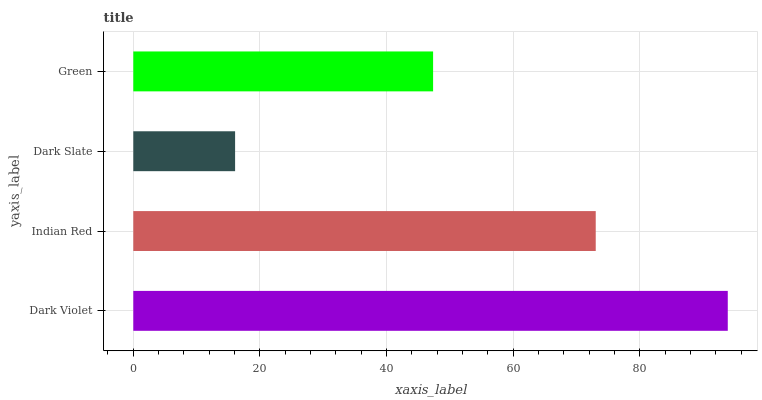Is Dark Slate the minimum?
Answer yes or no. Yes. Is Dark Violet the maximum?
Answer yes or no. Yes. Is Indian Red the minimum?
Answer yes or no. No. Is Indian Red the maximum?
Answer yes or no. No. Is Dark Violet greater than Indian Red?
Answer yes or no. Yes. Is Indian Red less than Dark Violet?
Answer yes or no. Yes. Is Indian Red greater than Dark Violet?
Answer yes or no. No. Is Dark Violet less than Indian Red?
Answer yes or no. No. Is Indian Red the high median?
Answer yes or no. Yes. Is Green the low median?
Answer yes or no. Yes. Is Dark Violet the high median?
Answer yes or no. No. Is Dark Violet the low median?
Answer yes or no. No. 